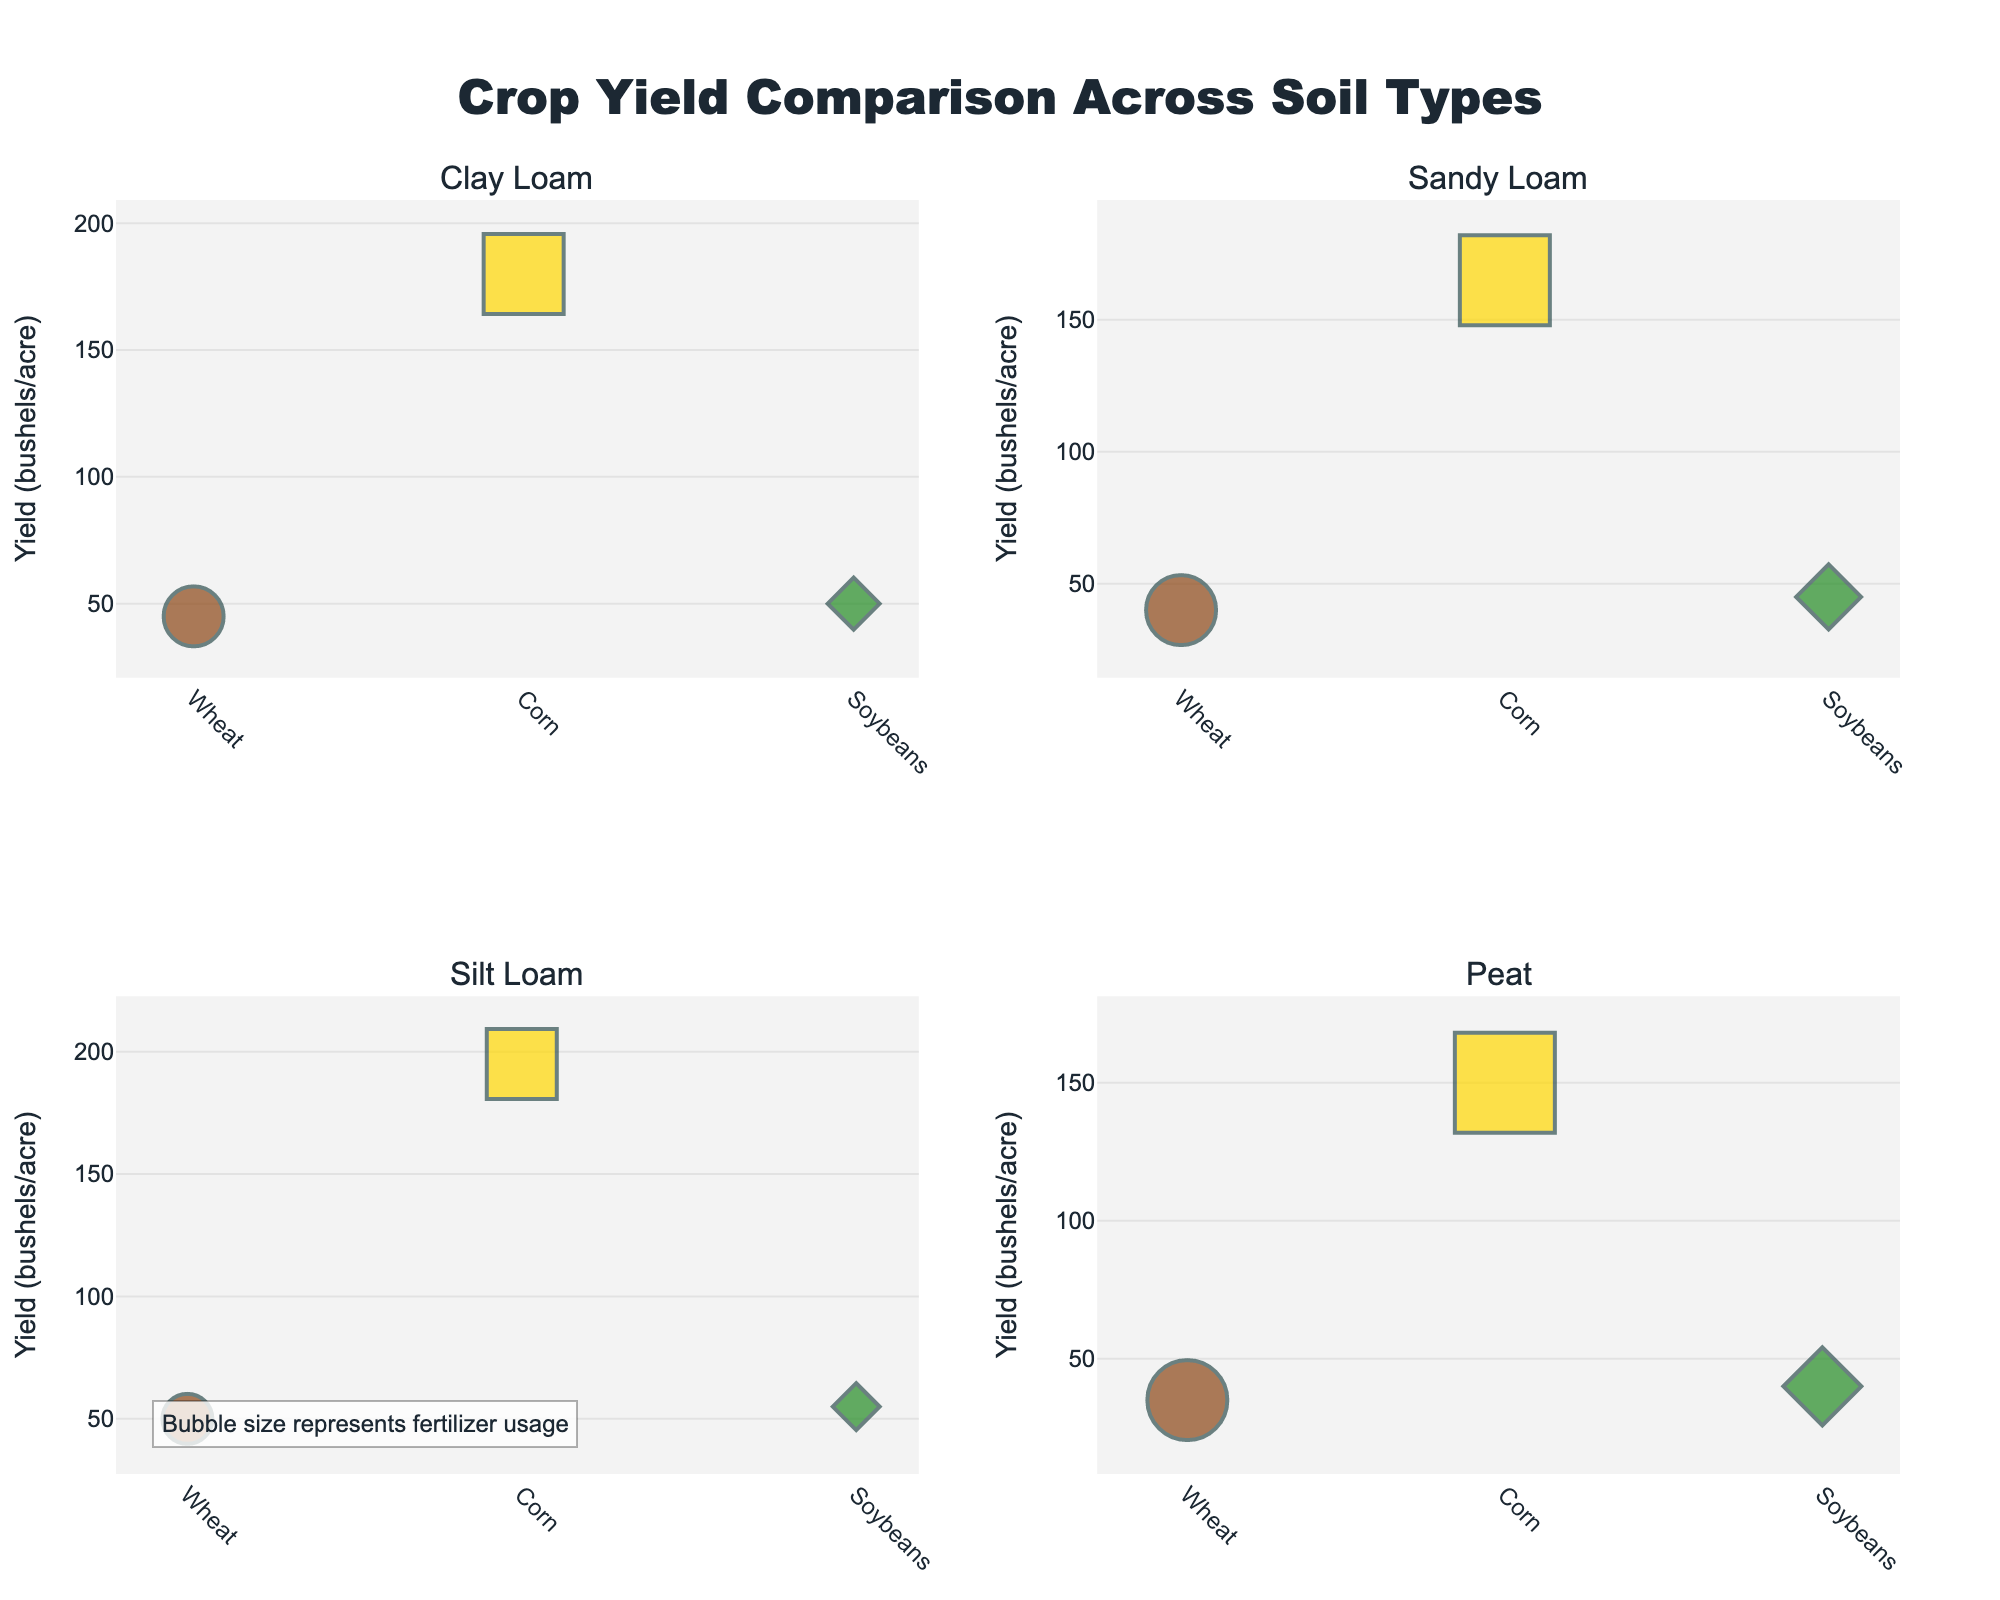How many soil types are compared in the figure? The figure contains subplots for each soil type. There are four subplots with titles "Clay Loam", "Sandy Loam", "Silt Loam", and "Peat", indicating that there are four different soil types being compared.
Answer: 4 What is the crop yield for Corn in the "Peat" soil type? Looking at the subplot titled "Peat", find the marker representing "Corn". The y-axis value for this marker represents the crop yield in bushels per acre.
Answer: 150 Which crop has the highest yield in "Sandy Loam"? In the "Sandy Loam" subplot, compare the y-axis values of the markers for Wheat, Corn, and Soybeans. Identify the highest value.
Answer: Corn Which soil type shows the highest yield for Soybeans? Look at the Soybeans markers in each subplot and compare their y-axis values (yield). The highest value determines the soil type with the highest yield for Soybeans.
Answer: Silt Loam What is the range of fertilizer usage for the "Wheat" crop across different soil types? Calculate the difference between the maximum and minimum fertilizer usage values for Wheat from all subplots. The values are 150 (Clay Loam), 175 (Sandy Loam), 125 (Silt Loam), and 200 (Peat). The range is 200 - 125.
Answer: 75 In which soil type does "Wheat" have the lowest yield? Check the yield values of Wheat in each subplot. Identify the subplot with the lowest y-axis value for Wheat.
Answer: Peat How does the fertilizer usage for Corn in "Silt Loam" compare to "Clay Loam"? Look at the Corn markers in both "Silt Loam" and "Clay Loam". Compare their bubble sizes or directly compare the numerical values from the provided data.
Answer: Silt Loam uses less fertilizer On average, which crop uses the most fertilizer across all soil types? Calculate the average fertilizer usage for Wheat, Corn, and Soybeans by summing up the fertilizer usage values for each crop across all soil types and dividing by the number of soil types (4). Corn: (200+225+175+250)/4, Wheat: (150+175+125+200)/4, Soybeans: (100+125+90+150)/4.
Answer: Corn 